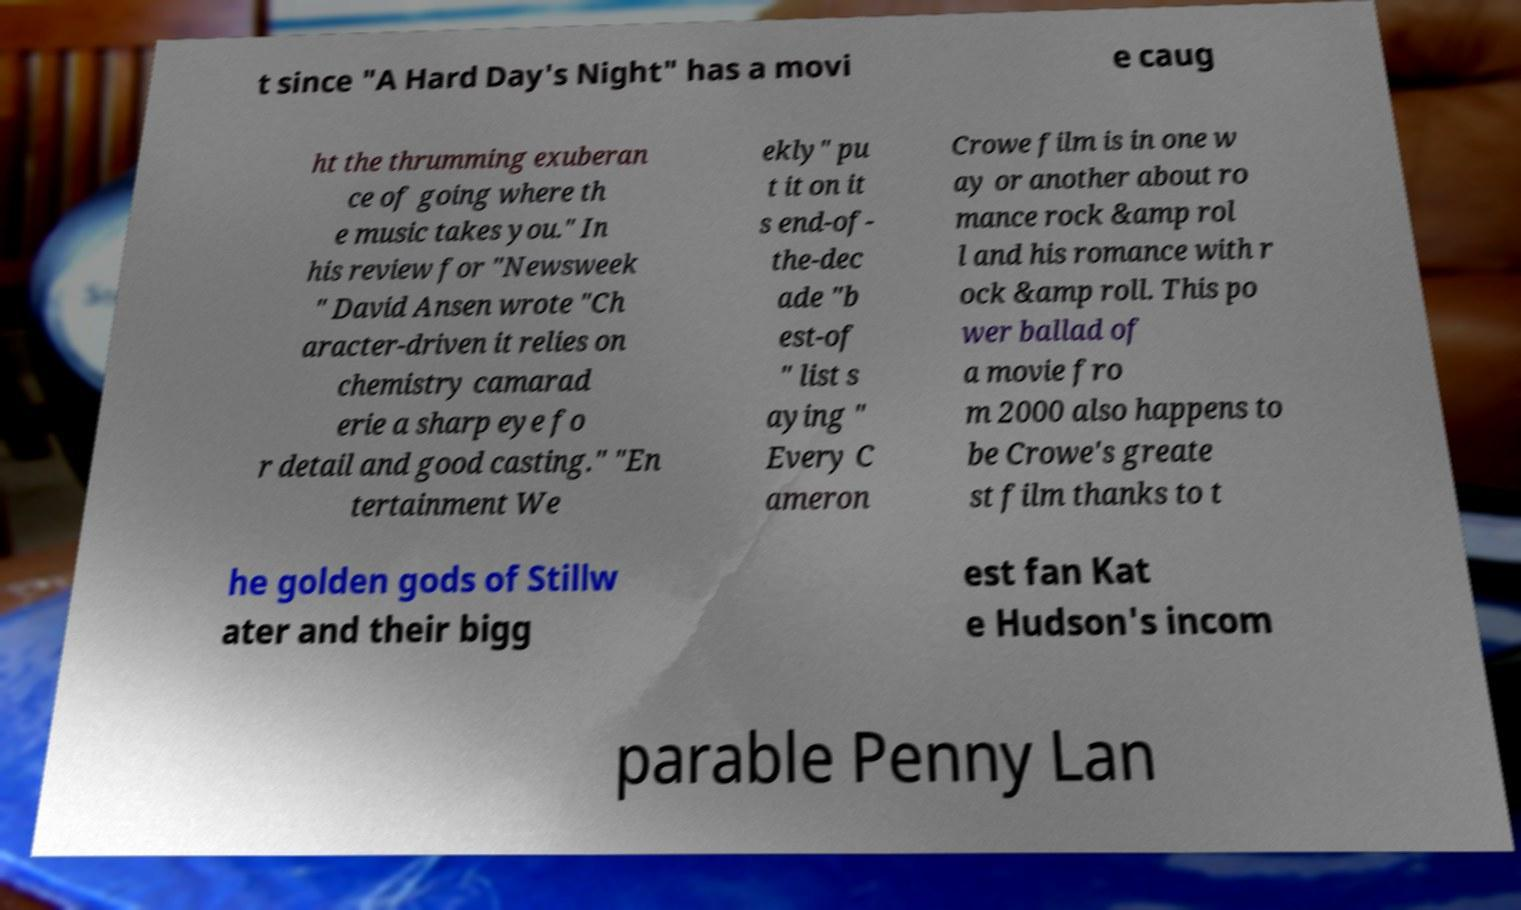Can you read and provide the text displayed in the image?This photo seems to have some interesting text. Can you extract and type it out for me? t since "A Hard Day's Night" has a movi e caug ht the thrumming exuberan ce of going where th e music takes you." In his review for "Newsweek " David Ansen wrote "Ch aracter-driven it relies on chemistry camarad erie a sharp eye fo r detail and good casting." "En tertainment We ekly" pu t it on it s end-of- the-dec ade "b est-of " list s aying " Every C ameron Crowe film is in one w ay or another about ro mance rock &amp rol l and his romance with r ock &amp roll. This po wer ballad of a movie fro m 2000 also happens to be Crowe's greate st film thanks to t he golden gods of Stillw ater and their bigg est fan Kat e Hudson's incom parable Penny Lan 